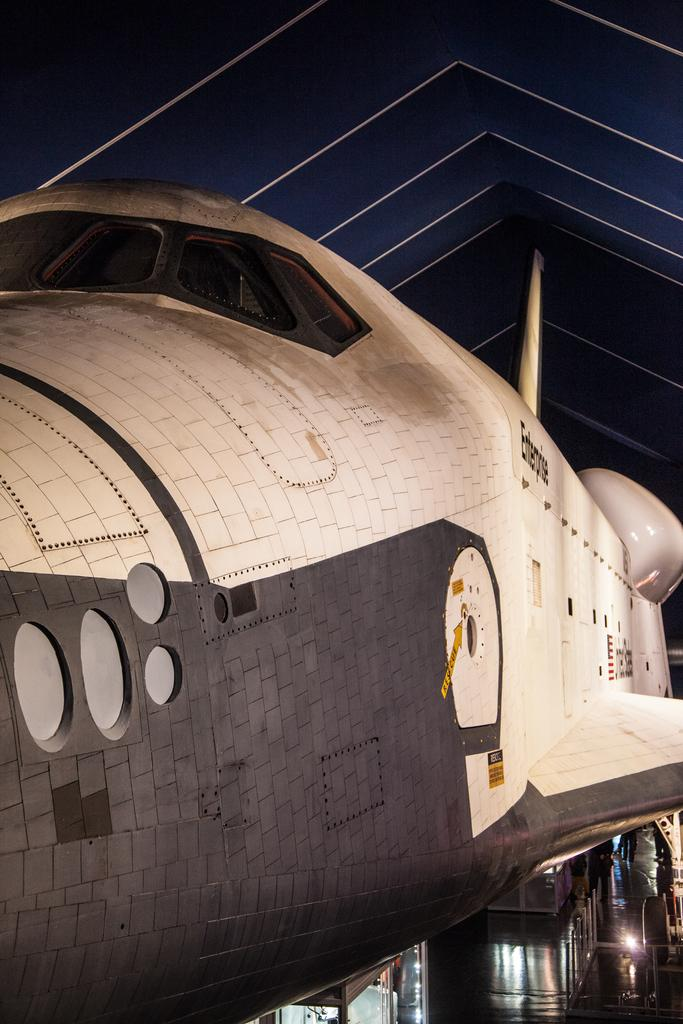What is the main subject of the image? The main subject of the image is an airplane. What else can be seen in the image besides the airplane? There are lights visible in the image. What type of ink is being used to write on the airplane in the image? There is no ink or writing present on the airplane in the image. How does the spark from the lights in the image affect the airplane? There is no spark or indication of a spark in the image, and therefore it cannot affect the airplane. 